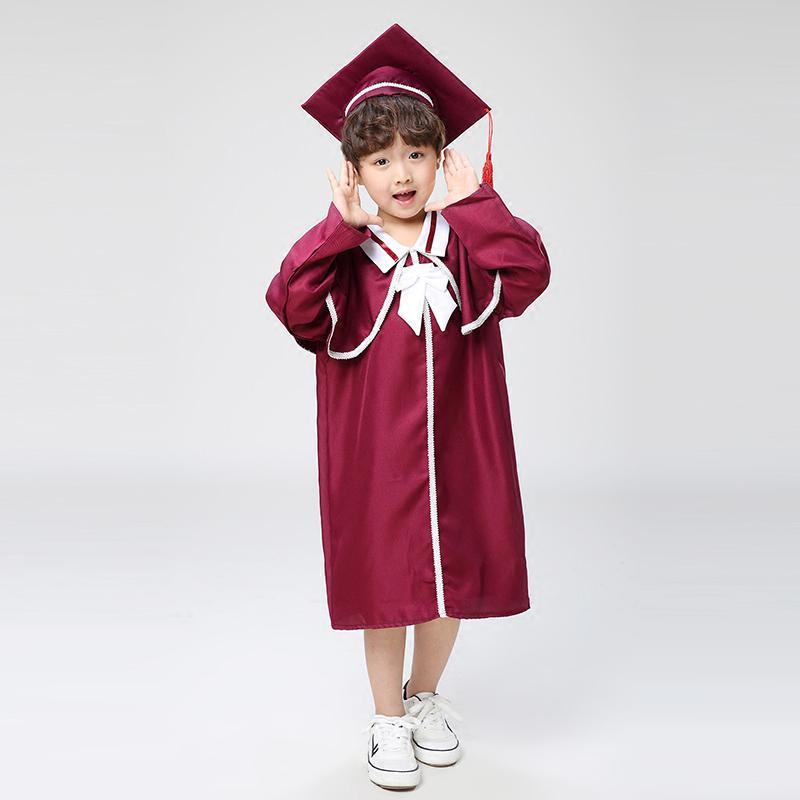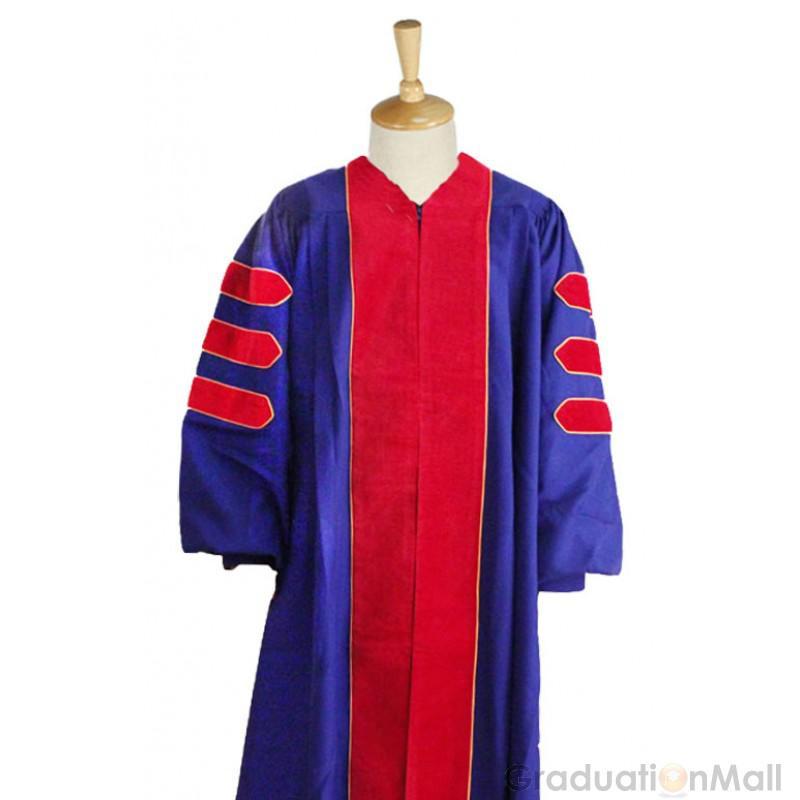The first image is the image on the left, the second image is the image on the right. Analyze the images presented: Is the assertion "There are two images of people wearing graduation caps that have tassels hanging to the right." valid? Answer yes or no. No. The first image is the image on the left, the second image is the image on the right. Evaluate the accuracy of this statement regarding the images: "The image on the left shows a student in graduation attire holding a diploma in their hands.". Is it true? Answer yes or no. No. 